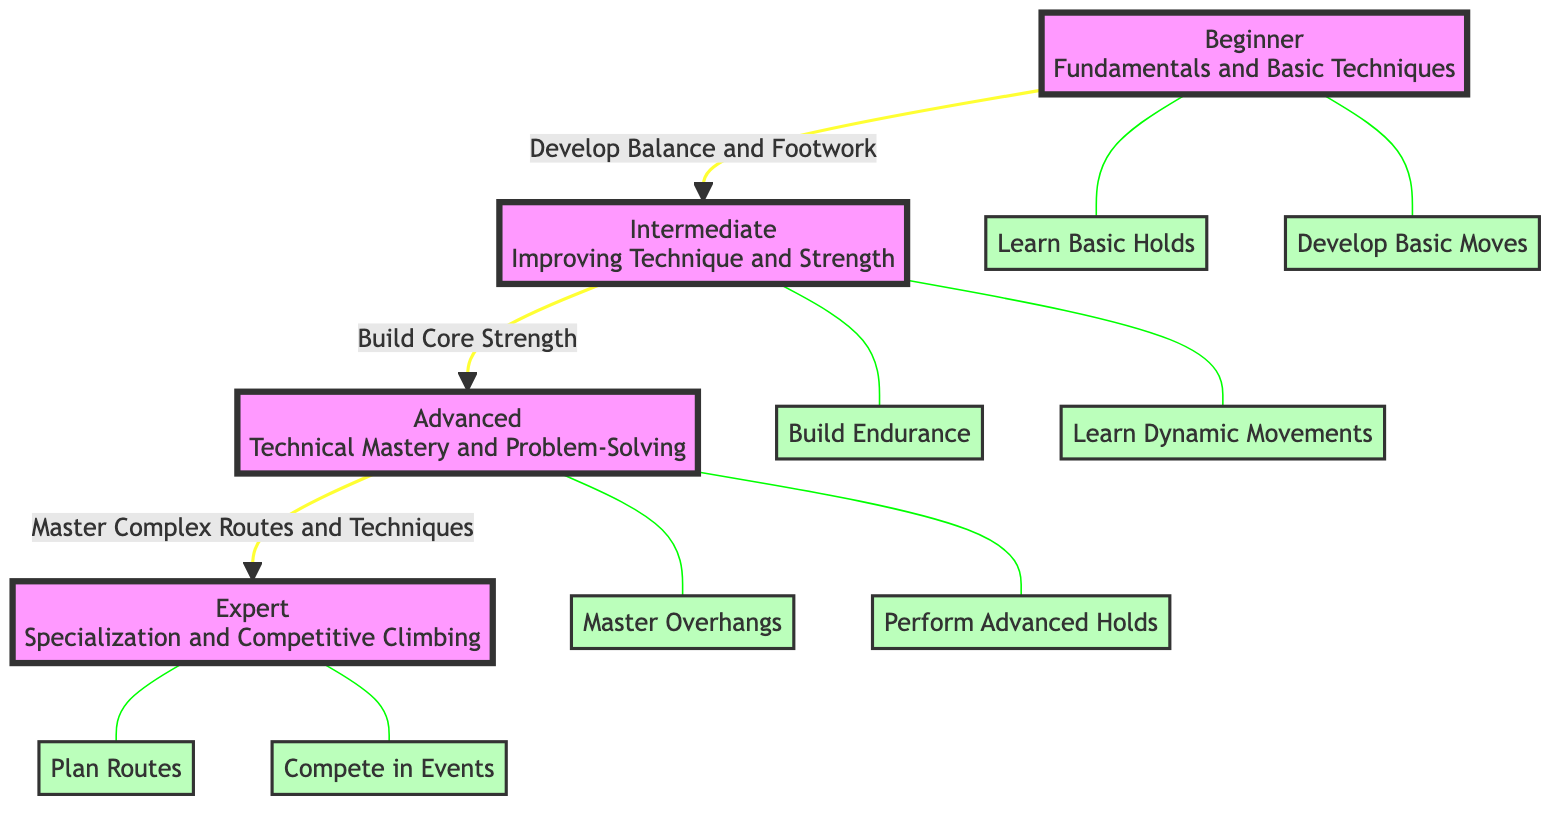What are the four skill levels depicted in the diagram? The diagram shows four skill levels: Beginner, Intermediate, Advanced, and Expert. These levels are clearly identified as distinct nodes in the flowchart.
Answer: Beginner, Intermediate, Advanced, Expert How many milestones are associated with the Advanced skill level? The Advanced skill level has two associated milestones: "Master Overhangs" and "Perform Advanced Holds." This is determined by counting the connections branching from the Advanced node.
Answer: 2 What is the relationship between the Beginner and Intermediate levels? The relationship between Beginner and Intermediate levels is a directional progression, where one moves from Beginner to Intermediate, specifically labeled as "Develop Balance and Footwork." This indicates a clear advancement in skills.
Answer: Develop Balance and Footwork Which milestone comes first in the Beginner skill level? The first milestone under Beginner is "Learn Basic Holds." This information is found by observing the milestones connected to the Beginner node.
Answer: Learn Basic Holds How do you progress from Intermediate to Advanced in the diagram? Progressing from Intermediate to Advanced requires building core strength, as indicated by the arrow connecting these two skill levels in the diagram. This highlights a necessary step between these stages.
Answer: Build Core Strength What is the final milestone for the Expert skill level? The final milestone for Expert is "Compete in Events." This is identified by comparing the listed milestones associated with the Expert node in the diagram.
Answer: Compete in Events How many total nodes are present in the diagram? The total number of nodes includes all skill levels and milestones, which amounts to a total of ten nodes in the diagram when counted.
Answer: 10 What is the primary focus of the Advanced skill level? The primary focus of the Advanced skill level is "Technical Mastery and Problem-Solving," which is directly stated in the node description for that level.
Answer: Technical Mastery and Problem-Solving What technique is emphasized when advancing from Beginner to Intermediate? The technique emphasized when advancing from Beginner to Intermediate is "Develop Balance and Footwork," highlighting the skills necessary for this progression.
Answer: Develop Balance and Footwork 